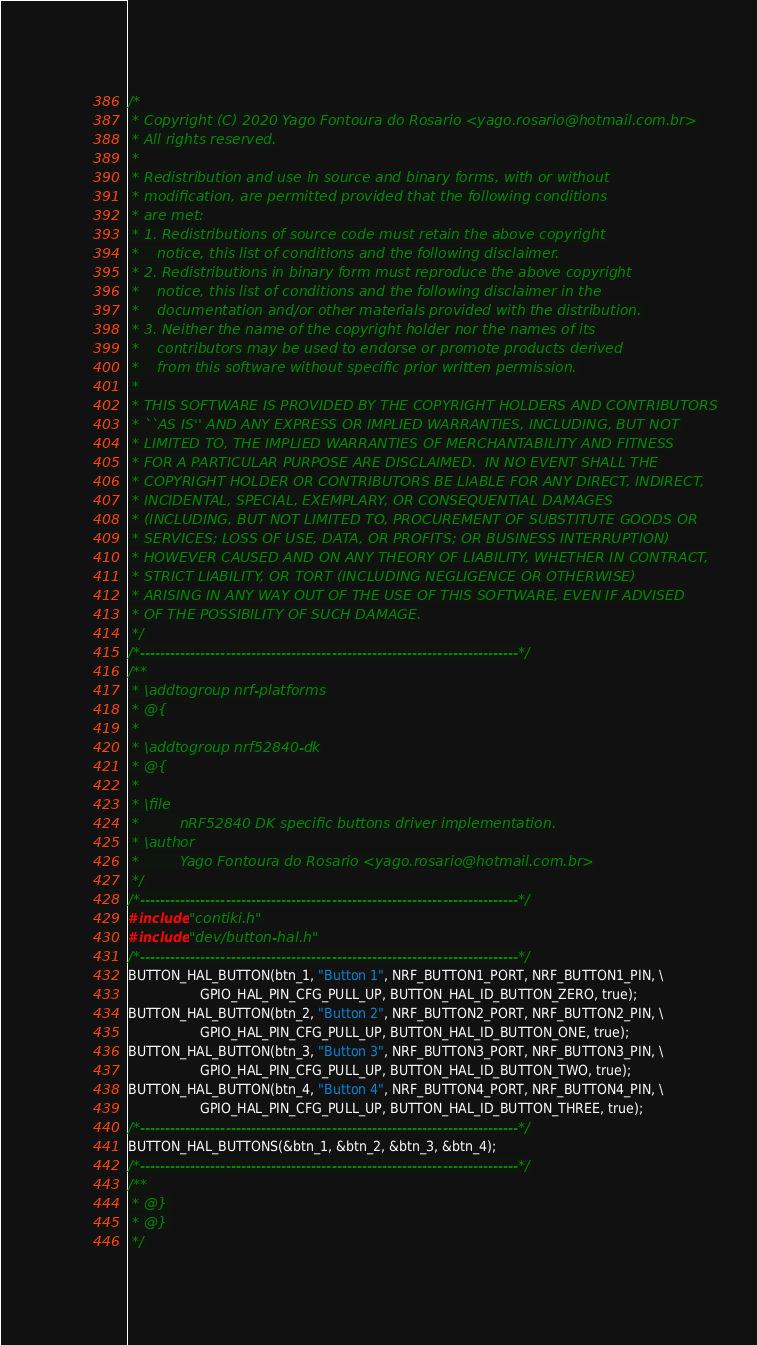<code> <loc_0><loc_0><loc_500><loc_500><_C_>/*
 * Copyright (C) 2020 Yago Fontoura do Rosario <yago.rosario@hotmail.com.br>
 * All rights reserved.
 *
 * Redistribution and use in source and binary forms, with or without
 * modification, are permitted provided that the following conditions
 * are met:
 * 1. Redistributions of source code must retain the above copyright
 *    notice, this list of conditions and the following disclaimer.
 * 2. Redistributions in binary form must reproduce the above copyright
 *    notice, this list of conditions and the following disclaimer in the
 *    documentation and/or other materials provided with the distribution.
 * 3. Neither the name of the copyright holder nor the names of its
 *    contributors may be used to endorse or promote products derived
 *    from this software without specific prior written permission.
 *
 * THIS SOFTWARE IS PROVIDED BY THE COPYRIGHT HOLDERS AND CONTRIBUTORS
 * ``AS IS'' AND ANY EXPRESS OR IMPLIED WARRANTIES, INCLUDING, BUT NOT
 * LIMITED TO, THE IMPLIED WARRANTIES OF MERCHANTABILITY AND FITNESS
 * FOR A PARTICULAR PURPOSE ARE DISCLAIMED.  IN NO EVENT SHALL THE
 * COPYRIGHT HOLDER OR CONTRIBUTORS BE LIABLE FOR ANY DIRECT, INDIRECT,
 * INCIDENTAL, SPECIAL, EXEMPLARY, OR CONSEQUENTIAL DAMAGES
 * (INCLUDING, BUT NOT LIMITED TO, PROCUREMENT OF SUBSTITUTE GOODS OR
 * SERVICES; LOSS OF USE, DATA, OR PROFITS; OR BUSINESS INTERRUPTION)
 * HOWEVER CAUSED AND ON ANY THEORY OF LIABILITY, WHETHER IN CONTRACT,
 * STRICT LIABILITY, OR TORT (INCLUDING NEGLIGENCE OR OTHERWISE)
 * ARISING IN ANY WAY OUT OF THE USE OF THIS SOFTWARE, EVEN IF ADVISED
 * OF THE POSSIBILITY OF SUCH DAMAGE.
 */
/*---------------------------------------------------------------------------*/
/**
 * \addtogroup nrf-platforms
 * @{
 *
 * \addtogroup nrf52840-dk
 * @{
 *
 * \file
 *         nRF52840 DK specific buttons driver implementation.
 * \author
 *         Yago Fontoura do Rosario <yago.rosario@hotmail.com.br>
 */
/*---------------------------------------------------------------------------*/
#include "contiki.h"
#include "dev/button-hal.h"
/*---------------------------------------------------------------------------*/
BUTTON_HAL_BUTTON(btn_1, "Button 1", NRF_BUTTON1_PORT, NRF_BUTTON1_PIN, \
                  GPIO_HAL_PIN_CFG_PULL_UP, BUTTON_HAL_ID_BUTTON_ZERO, true);
BUTTON_HAL_BUTTON(btn_2, "Button 2", NRF_BUTTON2_PORT, NRF_BUTTON2_PIN, \
                  GPIO_HAL_PIN_CFG_PULL_UP, BUTTON_HAL_ID_BUTTON_ONE, true);
BUTTON_HAL_BUTTON(btn_3, "Button 3", NRF_BUTTON3_PORT, NRF_BUTTON3_PIN, \
                  GPIO_HAL_PIN_CFG_PULL_UP, BUTTON_HAL_ID_BUTTON_TWO, true);
BUTTON_HAL_BUTTON(btn_4, "Button 4", NRF_BUTTON4_PORT, NRF_BUTTON4_PIN, \
                  GPIO_HAL_PIN_CFG_PULL_UP, BUTTON_HAL_ID_BUTTON_THREE, true);
/*---------------------------------------------------------------------------*/
BUTTON_HAL_BUTTONS(&btn_1, &btn_2, &btn_3, &btn_4);
/*---------------------------------------------------------------------------*/
/** 
 * @} 
 * @} 
 */
</code> 